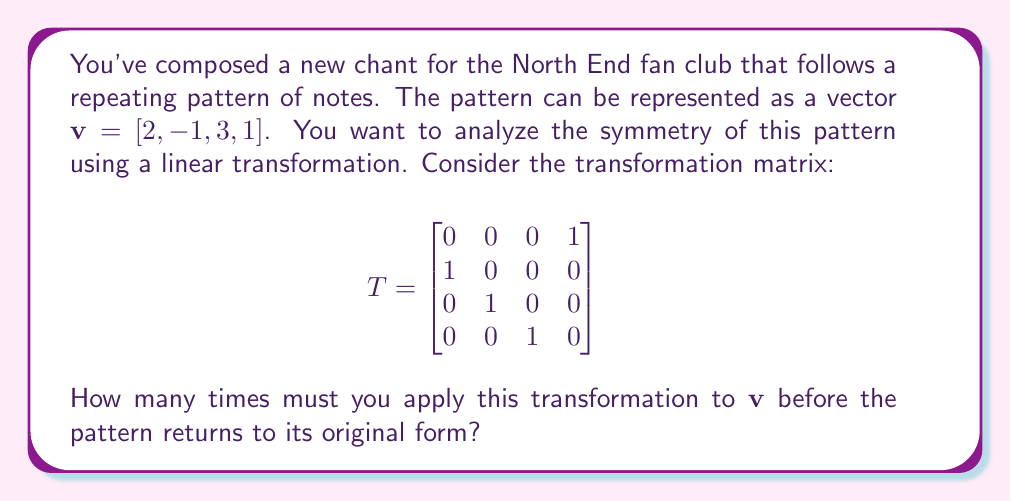Can you answer this question? Let's approach this step-by-step:

1) The transformation matrix $T$ is a cyclic permutation matrix. It shifts each element of the vector one position to the left, with the first element moving to the last position.

2) Let's see what happens when we apply $T$ to $\mathbf{v}$ multiple times:

   $T\mathbf{v} = [-1, 3, 1, 2]$
   $T^2\mathbf{v} = [3, 1, 2, -1]$
   $T^3\mathbf{v} = [1, 2, -1, 3]$
   $T^4\mathbf{v} = [2, -1, 3, 1]$

3) We see that after applying $T$ four times, we get back the original vector $\mathbf{v}$.

4) Mathematically, this means that $T^4 = I$, where $I$ is the 4x4 identity matrix.

5) The number of applications needed to return to the original form is called the order of the transformation. In this case, the order is 4.

6) This symmetry in the pattern is related to the concept of rotational symmetry in geometry, where a shape returns to its original orientation after a certain number of rotations.
Answer: 4 